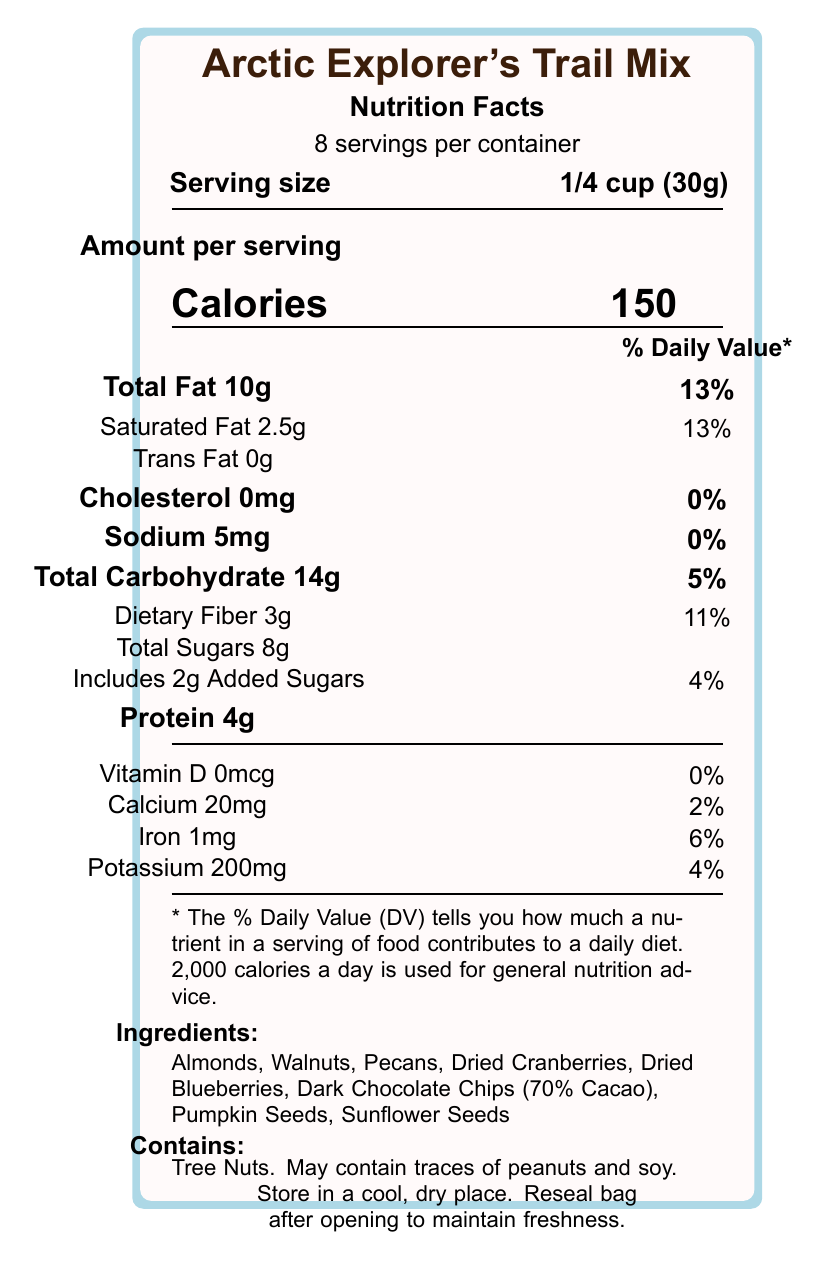what is the serving size? The serving size is directly listed on the document as "1/4 cup (30g)."
Answer: 1/4 cup (30g) how many calories are in one serving? The calories per serving are listed as "150" in the document.
Answer: 150 what is the total fat content per serving? The total fat per serving is noted as "10g."
Answer: 10g what percentage of the daily value of saturated fat does one serving provide? The daily value percentage for saturated fat per serving is listed as "13%."
Answer: 13% what is the amount of dietary fiber per serving? The amount of dietary fiber per serving is indicated as "3g."
Answer: 3g how many servings are there per container? The document specifies that there are "8 servings per container."
Answer: 8 what allergens are present in this trail mix? The allergen information is listed as "Contains: Tree Nuts. May contain traces of peanuts and soy."
Answer: Tree Nuts; May contain traces of peanuts and soy what ingredient provides antioxidants in the trail mix? The additional information section indicates that antioxidants come from dark chocolate and dried berries.
Answer: Dark Chocolate and Dried Berries how much added sugar is in one serving? The amount of added sugars is listed under the total sugars as "Includes 2g Added Sugars."
Answer: 2g which ingredient is a good source of omega-3 fatty acids? A. Almonds B. Walnuts C. Dried Cranberries D. Dark Chocolate The additional information states, "Good source of omega-3 fatty acids from walnuts."
Answer: B. Walnuts how much sodium is in each serving of the trail mix? The amount of sodium per serving is given as "5mg."
Answer: 5mg is there any vitamin D in this trail mix? The amount of vitamin D is listed as "0mcg," which translates to "0%."
Answer: No is this trail mix suitable for someone allergic to gluten? The document does not provide information regarding gluten content.
Answer: Cannot be determined what percentage of the daily value of iron does one serving provide? The daily value percentage for iron per serving is noted as "6%."
Answer: 6% what sustainability feature does the packaging have? The sustainability note mentions that the packaging is made from "30% post-consumer recycled materials."
Answer: Packaging made from 30% post-consumer recycled materials how should this trail mix be stored after opening? The storage instructions state, "Store in a cool, dry place. Reseal bag after opening to maintain freshness."
Answer: Store in a cool, dry place. Reseal bag after opening to maintain freshness. which of the following is not an ingredient in the Arctic Explorer's Trail Mix? A. Pumpkin Seeds B. Dried Cranberries C. Honey D. Dark Chocolate Chips Honey is not listed among the ingredients in the document.
Answer: C. Honey describe the key nutritional aspects and additional features of the Arctic Explorer's Trail Mix. The document outlines various nutrients and health benefits of the trail mix. The ingredients provide rich sources of antioxidants, omega-3 fatty acids, vitamin E, and magnesium. The storage recommendations and the sustainability note of the packaging are also specified.
Answer: The Arctic Explorer's Trail Mix provides 150 calories per serving, with significant nutrients such as 10g of total fat, 3g of dietary fiber, and 4g of protein. It is packed with antioxidants from dark chocolate and dried berries, omega-3 fatty acids from walnuts, and is a good source of vitamin E and magnesium. Storage should be in a cool, dry place, and the packaging is made from 30% post-consumer recycled materials. what is the main objective of this document? The document details the nutritional content, health benefits, allergen information, storage instructions, and sustainability note for the Arctic Explorer's Trail Mix.
Answer: To present the nutritional information and health benefits of the Arctic Explorer's Trail Mix while providing instructions for storage and highlighting sustainability aspects of the packaging. 